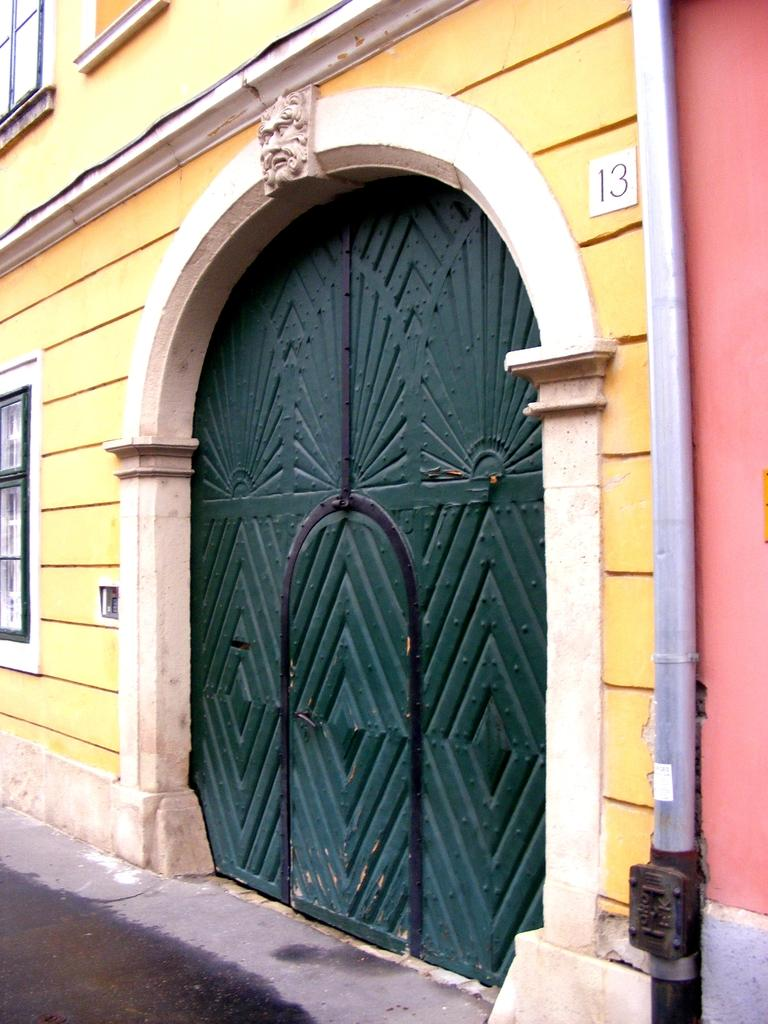What type of structure is visible in the image? There is a building in the image. What features can be seen on the building? The building has windows and a door. What architectural element is present in the image? There is an arch in the image. What is on top of the arch? There is a sculpture on the arch. What can be found on the wall of the building? There is a number on the wall and a pipe on the wall. What type of flesh can be seen hanging from the pipe in the image? There is no flesh present in the image; the pipe is attached to the wall with no visible objects hanging from it. 